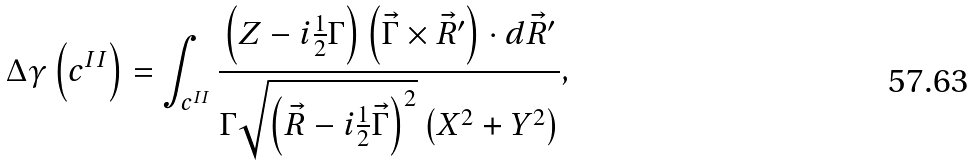Convert formula to latex. <formula><loc_0><loc_0><loc_500><loc_500>\Delta \gamma \left ( { c } ^ { I I } \right ) = \int _ { { c } ^ { I I } } \frac { \left ( Z - i \frac { 1 } { 2 } \Gamma \right ) \left ( \vec { \Gamma } \times \vec { R } ^ { \prime } \right ) \cdot d \vec { R } ^ { \prime } } { \Gamma \sqrt { \left ( \vec { R } - i \frac { 1 } { 2 } \vec { \Gamma } \right ) ^ { 2 } } \left ( X ^ { 2 } + Y ^ { 2 } \right ) } ,</formula> 